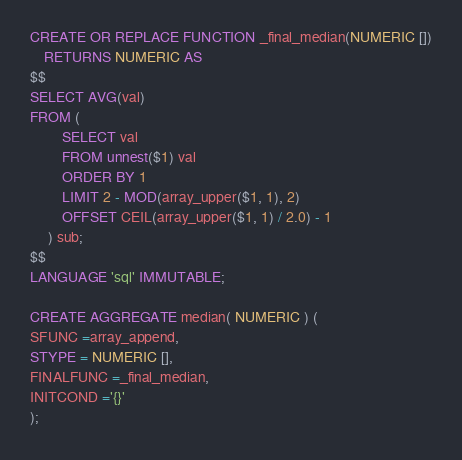Convert code to text. <code><loc_0><loc_0><loc_500><loc_500><_SQL_>
CREATE OR REPLACE FUNCTION _final_median(NUMERIC [])
	RETURNS NUMERIC AS
$$
SELECT AVG(val)
FROM (
	     SELECT val
	     FROM unnest($1) val
	     ORDER BY 1
	     LIMIT 2 - MOD(array_upper($1, 1), 2)
	     OFFSET CEIL(array_upper($1, 1) / 2.0) - 1
     ) sub;
$$
LANGUAGE 'sql' IMMUTABLE;

CREATE AGGREGATE median( NUMERIC ) (
SFUNC =array_append,
STYPE = NUMERIC [],
FINALFUNC =_final_median,
INITCOND ='{}'
);
</code> 